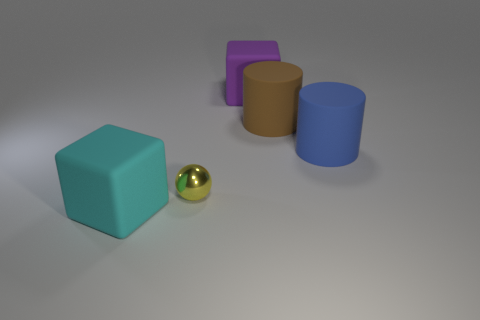What color is the object that is on the right side of the brown cylinder?
Give a very brief answer. Blue. There is a rubber block that is in front of the big blue object; is its color the same as the tiny metal sphere?
Your response must be concise. No. What material is the large purple object that is the same shape as the cyan object?
Ensure brevity in your answer.  Rubber. What number of purple objects are the same size as the blue cylinder?
Make the answer very short. 1. What shape is the tiny thing?
Your answer should be compact. Sphere. There is a rubber object that is both to the left of the big brown matte cylinder and in front of the large brown matte cylinder; what size is it?
Provide a short and direct response. Large. There is a big block that is in front of the tiny yellow metallic thing; what is it made of?
Offer a terse response. Rubber. Is the color of the tiny thing the same as the matte block that is right of the large cyan block?
Provide a short and direct response. No. What number of objects are either objects that are behind the sphere or rubber objects that are to the left of the large brown matte cylinder?
Offer a very short reply. 4. There is a object that is on the left side of the big brown cylinder and behind the large blue rubber cylinder; what is its color?
Your answer should be very brief. Purple. 